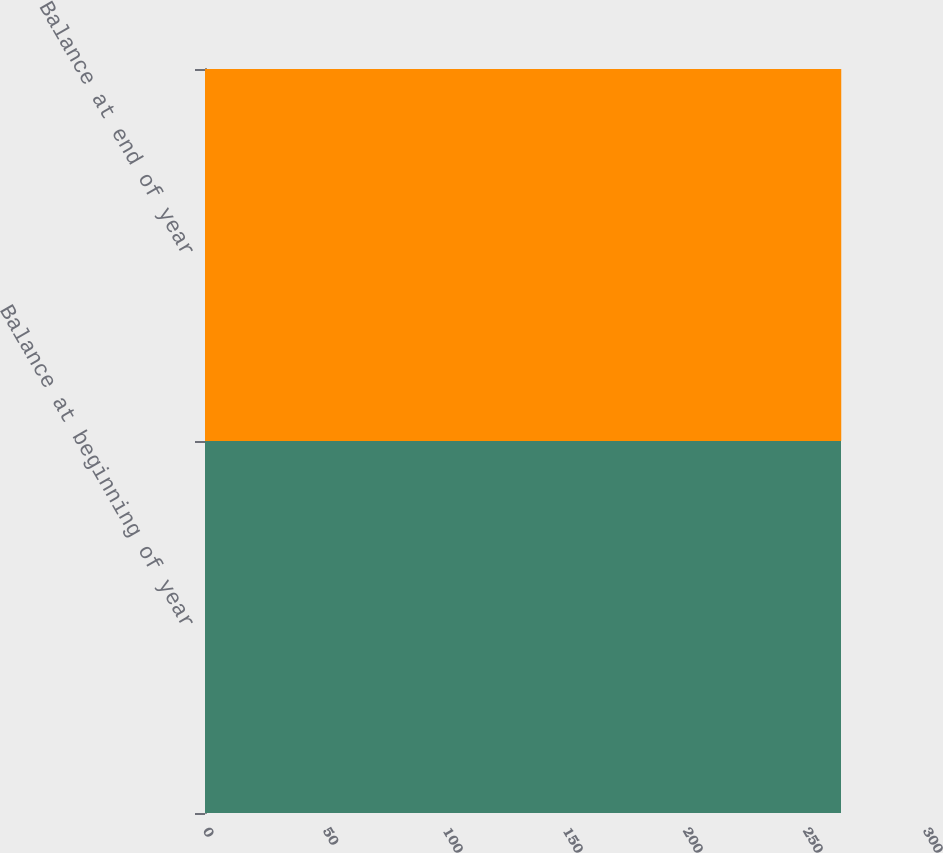<chart> <loc_0><loc_0><loc_500><loc_500><bar_chart><fcel>Balance at beginning of year<fcel>Balance at end of year<nl><fcel>265<fcel>265.1<nl></chart> 